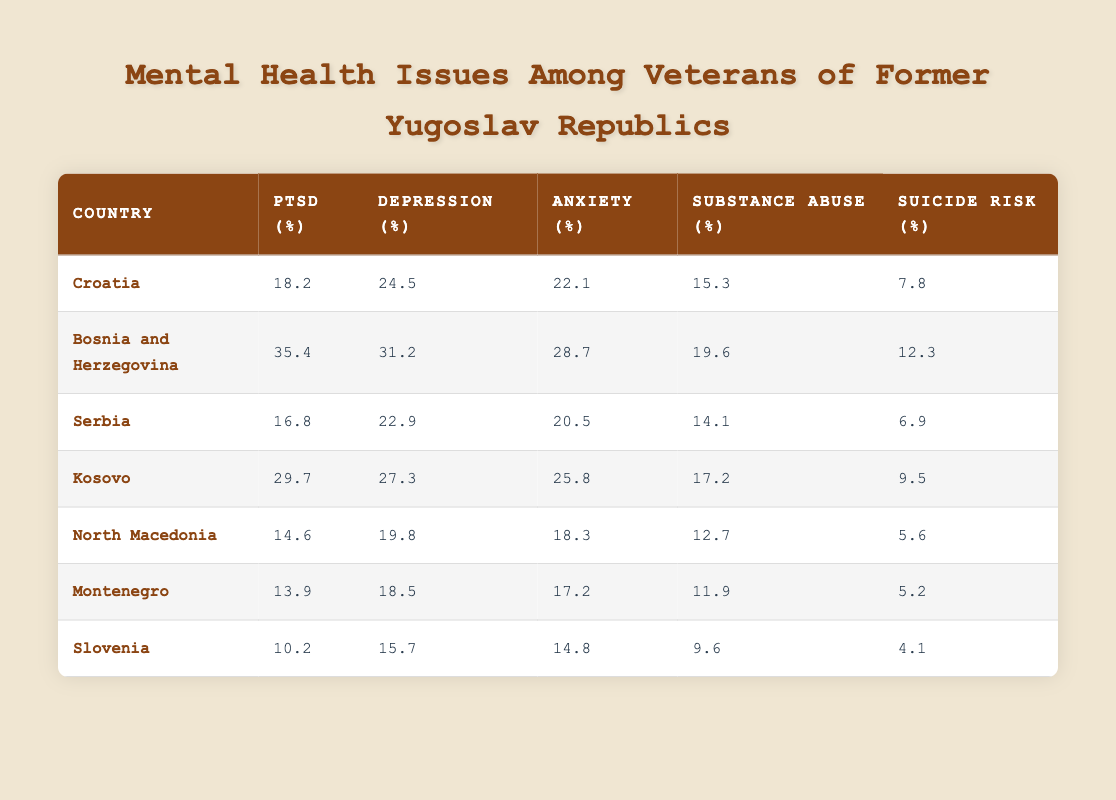What country has the highest percentage of PTSD among veterans? The table shows the percentage of PTSD for each country. By scanning the "PTSD (%)" column, it is evident that Bosnia and Herzegovina has the highest percentage at 35.4% compared to the others.
Answer: Bosnia and Herzegovina What is the average percentage of depression reported across these countries? To find the average percentage of depression, add the values (24.5 + 31.2 + 22.9 + 27.3 + 19.8 + 18.5 + 15.7) =  159.9 and then divide by the number of countries (7), which gives 159.9 / 7 ≈ 22.84.
Answer: Approximately 22.84 Which country reports the lowest suicide risk percentage? By looking at the "Suicide Risk (%)" column, Montenegro has the lowest percentage reported at 5.2%.
Answer: Montenegro Is the percentage of substance abuse higher in Kosovo than in Serbia? The table shows that Kosovo has a substance abuse percentage of 17.2% whereas Serbia has 14.1%. Since 17.2% is greater than 14.1%, the statement is true.
Answer: Yes What are the differences in anxiety percentage between Bosnia and Herzegovina and Slovenia? The anxiety percentage for Bosnia and Herzegovina is 28.7% and for Slovenia, it is 14.8%. The difference is calculated as 28.7 - 14.8 = 13.9%.
Answer: 13.9% 